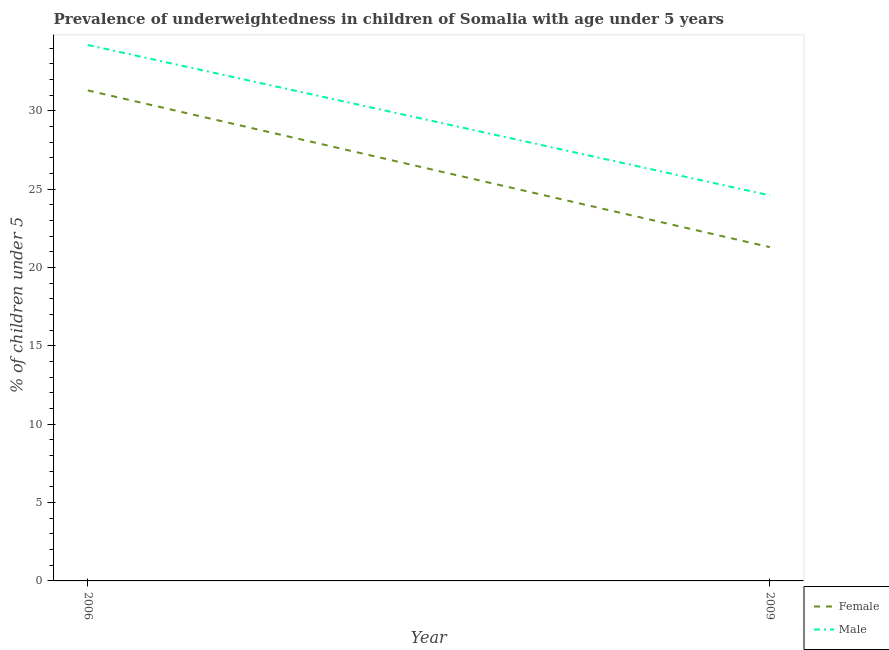Does the line corresponding to percentage of underweighted male children intersect with the line corresponding to percentage of underweighted female children?
Ensure brevity in your answer.  No. What is the percentage of underweighted male children in 2009?
Your response must be concise. 24.6. Across all years, what is the maximum percentage of underweighted male children?
Give a very brief answer. 34.2. Across all years, what is the minimum percentage of underweighted female children?
Your response must be concise. 21.3. In which year was the percentage of underweighted female children minimum?
Keep it short and to the point. 2009. What is the total percentage of underweighted male children in the graph?
Offer a very short reply. 58.8. What is the difference between the percentage of underweighted male children in 2006 and that in 2009?
Your response must be concise. 9.6. What is the difference between the percentage of underweighted male children in 2009 and the percentage of underweighted female children in 2006?
Keep it short and to the point. -6.7. What is the average percentage of underweighted female children per year?
Your response must be concise. 26.3. In the year 2006, what is the difference between the percentage of underweighted female children and percentage of underweighted male children?
Keep it short and to the point. -2.9. What is the ratio of the percentage of underweighted male children in 2006 to that in 2009?
Keep it short and to the point. 1.39. Does the percentage of underweighted male children monotonically increase over the years?
Offer a very short reply. No. Is the percentage of underweighted female children strictly greater than the percentage of underweighted male children over the years?
Give a very brief answer. No. How many lines are there?
Provide a short and direct response. 2. How many years are there in the graph?
Provide a succinct answer. 2. Are the values on the major ticks of Y-axis written in scientific E-notation?
Offer a terse response. No. Does the graph contain any zero values?
Provide a succinct answer. No. Does the graph contain grids?
Provide a short and direct response. No. How many legend labels are there?
Ensure brevity in your answer.  2. How are the legend labels stacked?
Ensure brevity in your answer.  Vertical. What is the title of the graph?
Provide a short and direct response. Prevalence of underweightedness in children of Somalia with age under 5 years. Does "Travel Items" appear as one of the legend labels in the graph?
Your response must be concise. No. What is the label or title of the X-axis?
Your response must be concise. Year. What is the label or title of the Y-axis?
Offer a very short reply.  % of children under 5. What is the  % of children under 5 in Female in 2006?
Make the answer very short. 31.3. What is the  % of children under 5 in Male in 2006?
Give a very brief answer. 34.2. What is the  % of children under 5 of Female in 2009?
Your answer should be very brief. 21.3. What is the  % of children under 5 of Male in 2009?
Offer a terse response. 24.6. Across all years, what is the maximum  % of children under 5 in Female?
Your answer should be compact. 31.3. Across all years, what is the maximum  % of children under 5 in Male?
Offer a very short reply. 34.2. Across all years, what is the minimum  % of children under 5 in Female?
Provide a short and direct response. 21.3. Across all years, what is the minimum  % of children under 5 in Male?
Your response must be concise. 24.6. What is the total  % of children under 5 in Female in the graph?
Provide a succinct answer. 52.6. What is the total  % of children under 5 of Male in the graph?
Give a very brief answer. 58.8. What is the difference between the  % of children under 5 of Female in 2006 and the  % of children under 5 of Male in 2009?
Give a very brief answer. 6.7. What is the average  % of children under 5 of Female per year?
Ensure brevity in your answer.  26.3. What is the average  % of children under 5 in Male per year?
Your answer should be compact. 29.4. In the year 2006, what is the difference between the  % of children under 5 of Female and  % of children under 5 of Male?
Keep it short and to the point. -2.9. What is the ratio of the  % of children under 5 of Female in 2006 to that in 2009?
Your response must be concise. 1.47. What is the ratio of the  % of children under 5 in Male in 2006 to that in 2009?
Your response must be concise. 1.39. 